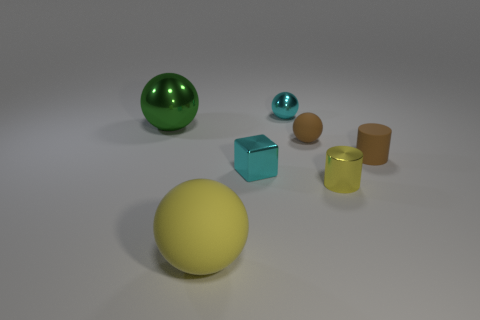Can you describe the lighting in this scene? The scene is illuminated by a soft and diffused light source coming from above, casting gentle shadows beneath each object and contributing to the serene atmosphere. 